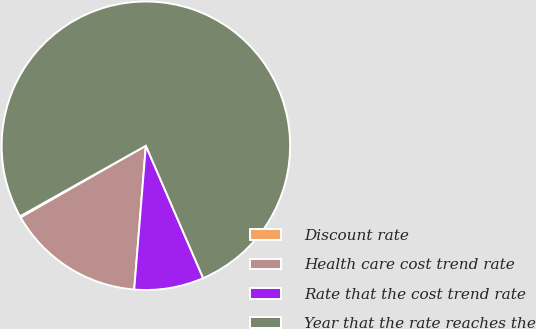Convert chart to OTSL. <chart><loc_0><loc_0><loc_500><loc_500><pie_chart><fcel>Discount rate<fcel>Health care cost trend rate<fcel>Rate that the cost trend rate<fcel>Year that the rate reaches the<nl><fcel>0.14%<fcel>15.44%<fcel>7.79%<fcel>76.63%<nl></chart> 